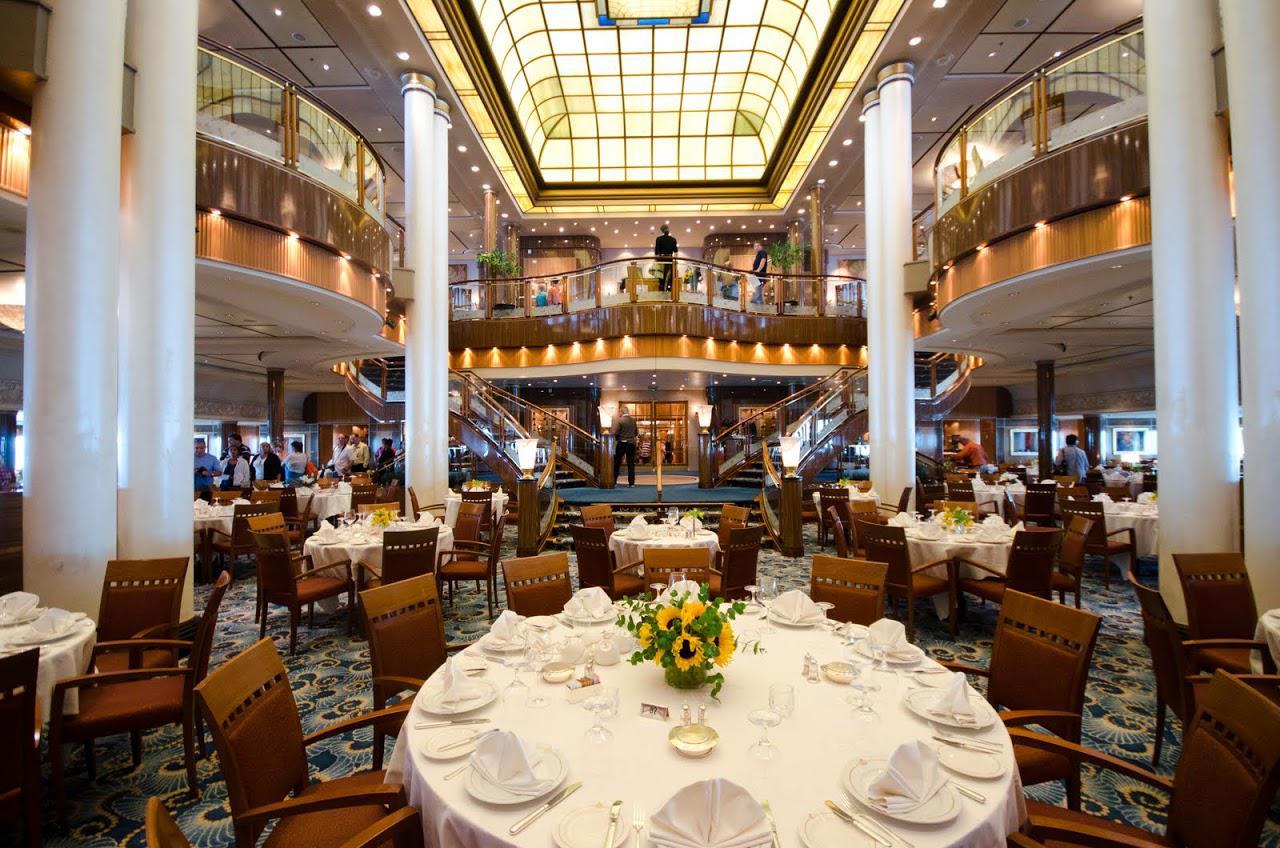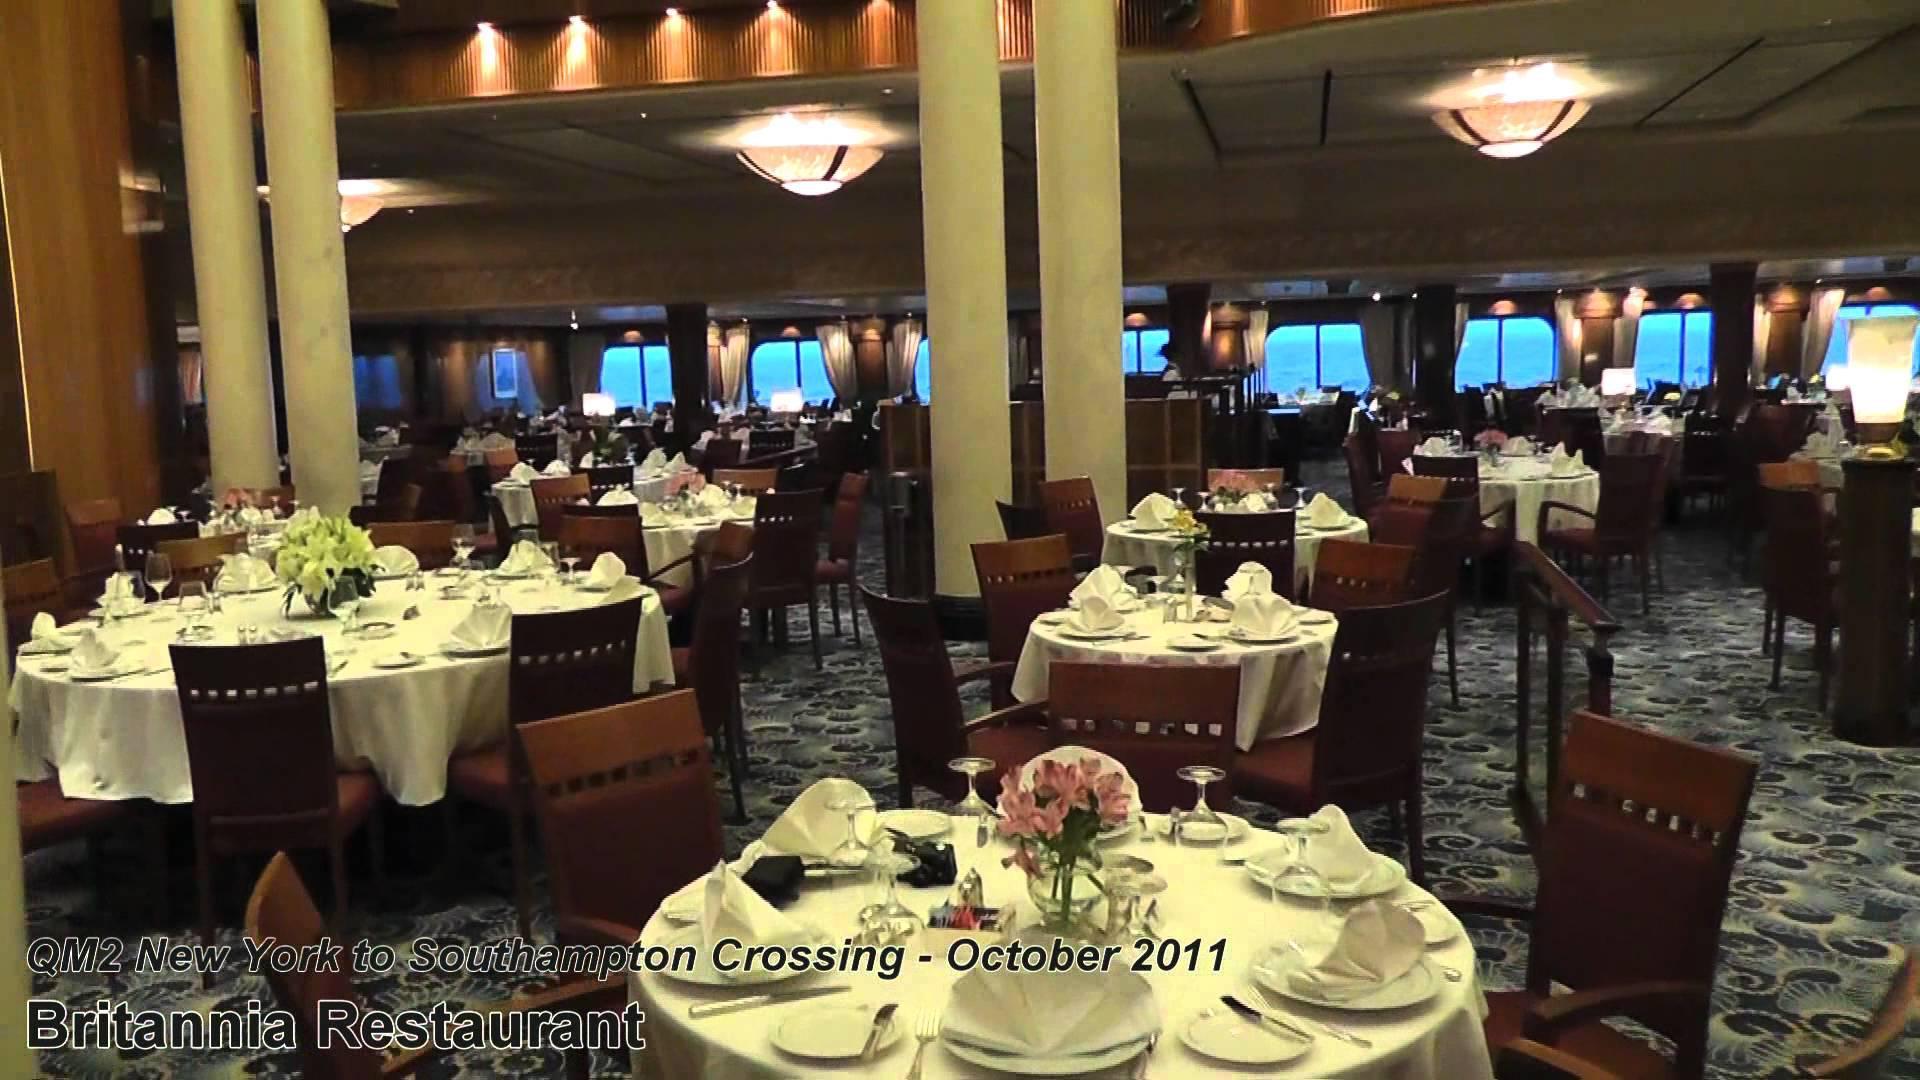The first image is the image on the left, the second image is the image on the right. Considering the images on both sides, is "There is a large skylight visible in at least one of the images." valid? Answer yes or no. Yes. The first image is the image on the left, the second image is the image on the right. Evaluate the accuracy of this statement regarding the images: "One of the images has chairs with red upholstery and white backs.". Is it true? Answer yes or no. No. 